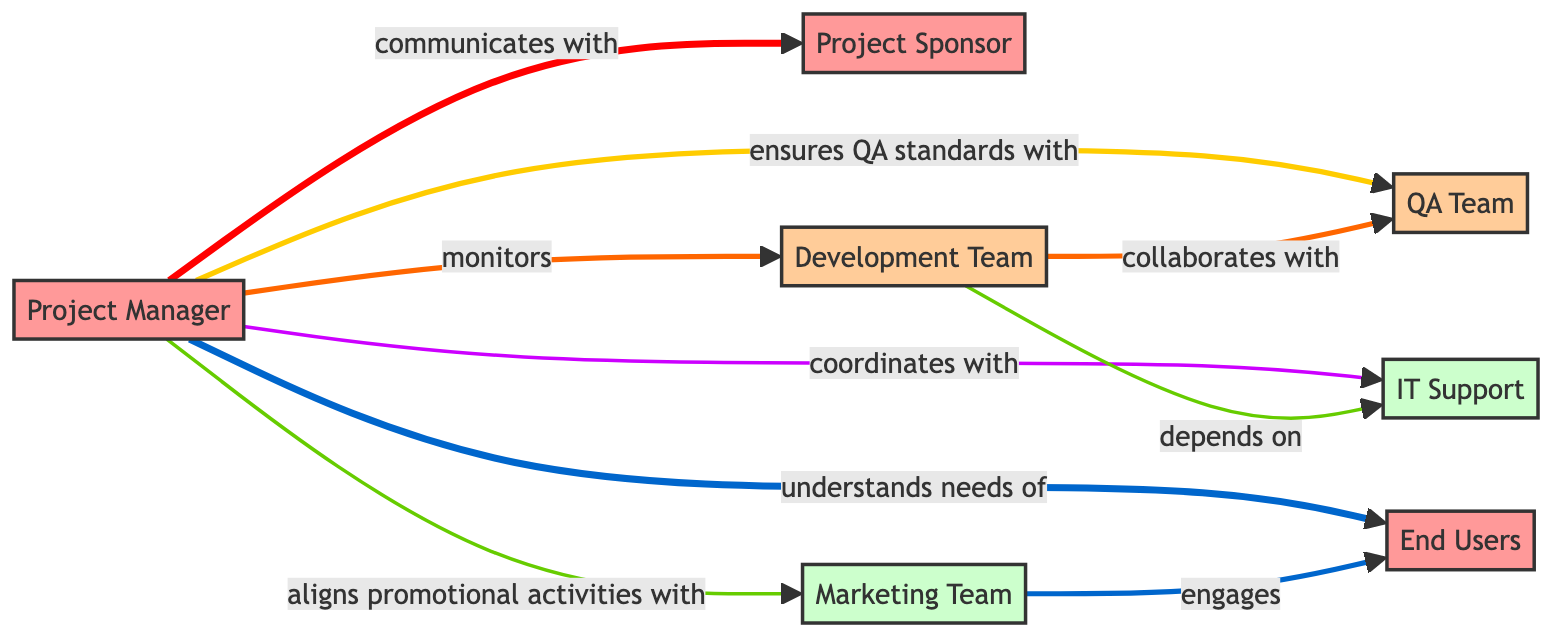What is the role of the Project Manager? The Project Manager is responsible for monitoring project timelines and cultivating a positive working environment.
Answer: Monitors project timelines and cultivates a positive working environment How many stakeholders are in the diagram? By counting the nodes, we identify that there are seven stakeholders represented in the diagram.
Answer: 7 What is the influence level of the Project Sponsor? The influence level indicated for the Project Sponsor is 10, which suggests a strong impact on the project.
Answer: 10 Which team engages with the End Users? The Marketing Team is indicated as the one that engages with the End Users in the diagram.
Answer: Marketing Team What is the strength of the communication between the Project Manager and the Development Team? The strength of the communication, labeled as "monitors," between the Project Manager and the Development Team is 8, indicating a strong monitoring relationship.
Answer: 8 Who does the Development Team depend on? According to the diagram, the Development Team depends on IT Support.
Answer: IT Support Which relationship is the strongest in the diagram? The strongest relationship is the one where the Project Manager "understands needs of" End Users, with a strength of 10.
Answer: understands needs of What type of relationship exists between the Development Team and QA Team? The relationship is characterized as "collaborates with," showing that they work together on shared tasks.
Answer: collaborates with Which node has the lowest influence level? The node with the lowest influence level is IT Support, with a value of 4.
Answer: IT Support 